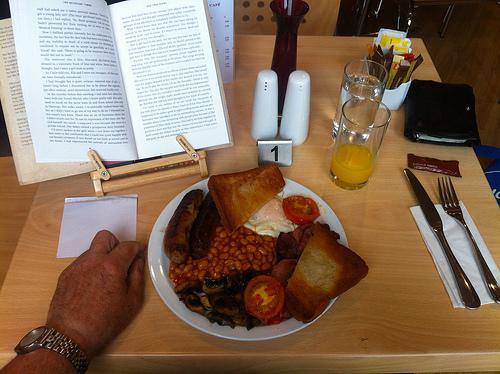Question: when was the picture taken?
Choices:
A. At twilight.
B. At breakfast time.
C. At noon.
D. At midnight.
Answer with the letter. Answer: B Question: why are two white containers on the table?
Choices:
A. For hotsauce and pepper.
B. For salt and hotsauce.
C. For chili and hotsauce.
D. For salt and pepper.
Answer with the letter. Answer: D Question: how many hands are on the table?
Choices:
A. Three.
B. Four.
C. Two.
D. One.
Answer with the letter. Answer: D Question: where is the table?
Choices:
A. A restaurant.
B. A bank.
C. A hospital.
D. A store.
Answer with the letter. Answer: A 